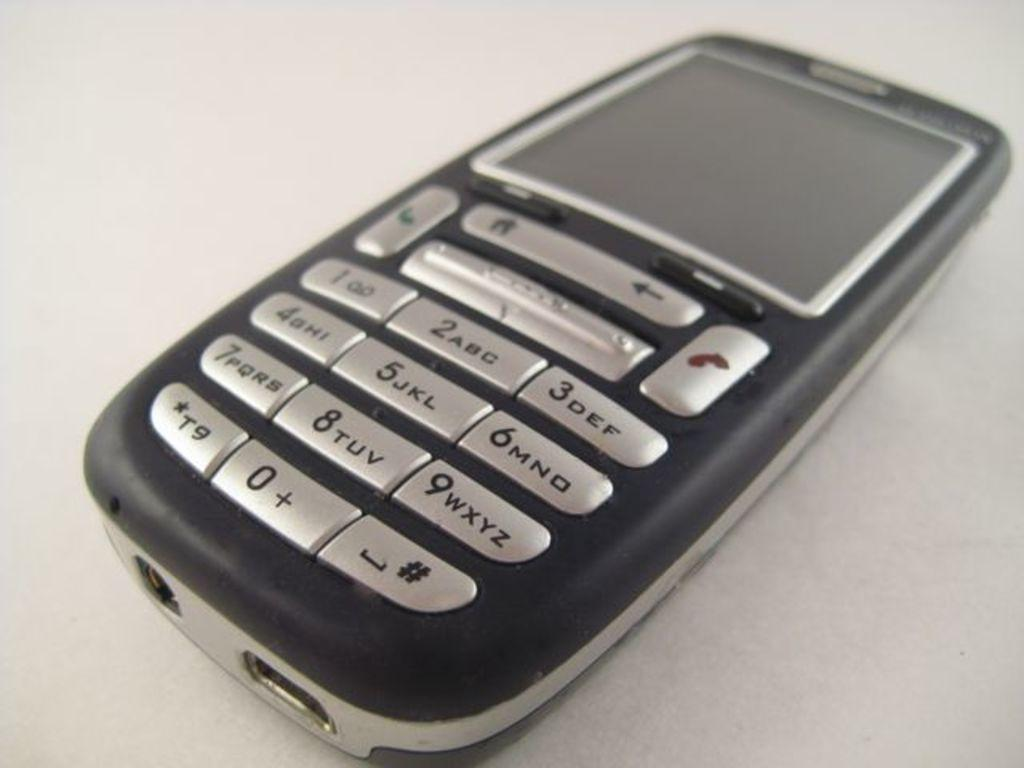Provide a one-sentence caption for the provided image. A small phone has silver buttons and the 9 key says WXYZ. 